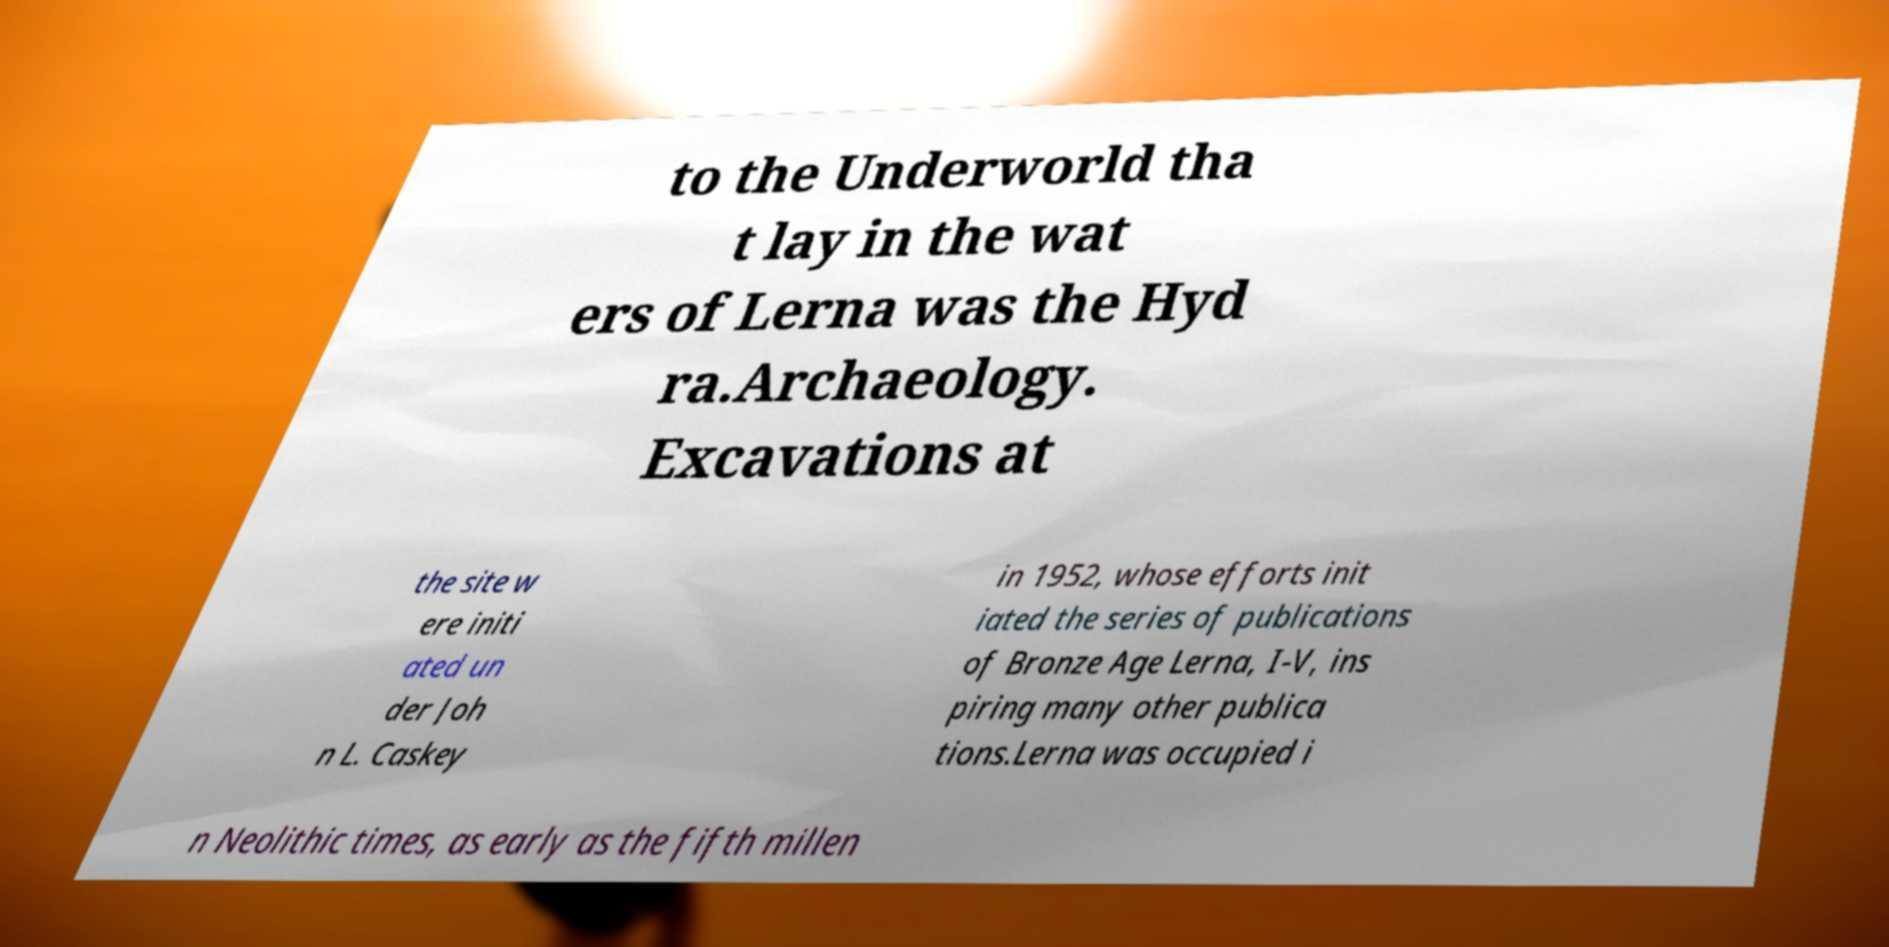Please read and relay the text visible in this image. What does it say? to the Underworld tha t lay in the wat ers of Lerna was the Hyd ra.Archaeology. Excavations at the site w ere initi ated un der Joh n L. Caskey in 1952, whose efforts init iated the series of publications of Bronze Age Lerna, I-V, ins piring many other publica tions.Lerna was occupied i n Neolithic times, as early as the fifth millen 